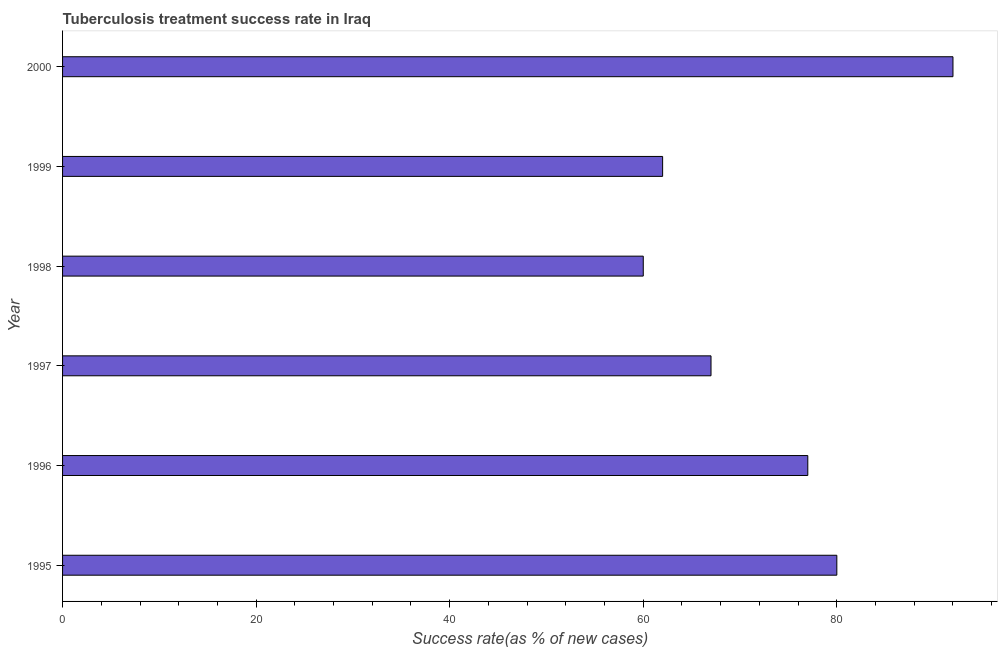Does the graph contain any zero values?
Provide a succinct answer. No. Does the graph contain grids?
Give a very brief answer. No. What is the title of the graph?
Provide a succinct answer. Tuberculosis treatment success rate in Iraq. What is the label or title of the X-axis?
Your answer should be very brief. Success rate(as % of new cases). What is the label or title of the Y-axis?
Ensure brevity in your answer.  Year. Across all years, what is the maximum tuberculosis treatment success rate?
Keep it short and to the point. 92. Across all years, what is the minimum tuberculosis treatment success rate?
Your answer should be compact. 60. In which year was the tuberculosis treatment success rate maximum?
Your response must be concise. 2000. In which year was the tuberculosis treatment success rate minimum?
Provide a short and direct response. 1998. What is the sum of the tuberculosis treatment success rate?
Make the answer very short. 438. What is the difference between the tuberculosis treatment success rate in 1997 and 2000?
Provide a short and direct response. -25. What is the median tuberculosis treatment success rate?
Make the answer very short. 72. Do a majority of the years between 1995 and 1996 (inclusive) have tuberculosis treatment success rate greater than 64 %?
Ensure brevity in your answer.  Yes. What is the ratio of the tuberculosis treatment success rate in 1995 to that in 1996?
Offer a terse response. 1.04. Is the tuberculosis treatment success rate in 1996 less than that in 1997?
Keep it short and to the point. No. Is the difference between the tuberculosis treatment success rate in 1997 and 1999 greater than the difference between any two years?
Offer a very short reply. No. What is the difference between the highest and the second highest tuberculosis treatment success rate?
Offer a very short reply. 12. What is the difference between the highest and the lowest tuberculosis treatment success rate?
Your answer should be very brief. 32. How many years are there in the graph?
Offer a very short reply. 6. What is the difference between two consecutive major ticks on the X-axis?
Your answer should be compact. 20. What is the Success rate(as % of new cases) in 1996?
Offer a very short reply. 77. What is the Success rate(as % of new cases) of 1997?
Offer a terse response. 67. What is the Success rate(as % of new cases) in 1998?
Provide a succinct answer. 60. What is the Success rate(as % of new cases) in 2000?
Offer a very short reply. 92. What is the difference between the Success rate(as % of new cases) in 1995 and 1997?
Provide a succinct answer. 13. What is the difference between the Success rate(as % of new cases) in 1995 and 1998?
Your answer should be very brief. 20. What is the difference between the Success rate(as % of new cases) in 1996 and 1999?
Ensure brevity in your answer.  15. What is the difference between the Success rate(as % of new cases) in 1998 and 1999?
Provide a short and direct response. -2. What is the difference between the Success rate(as % of new cases) in 1998 and 2000?
Offer a very short reply. -32. What is the difference between the Success rate(as % of new cases) in 1999 and 2000?
Provide a succinct answer. -30. What is the ratio of the Success rate(as % of new cases) in 1995 to that in 1996?
Your response must be concise. 1.04. What is the ratio of the Success rate(as % of new cases) in 1995 to that in 1997?
Offer a terse response. 1.19. What is the ratio of the Success rate(as % of new cases) in 1995 to that in 1998?
Give a very brief answer. 1.33. What is the ratio of the Success rate(as % of new cases) in 1995 to that in 1999?
Your answer should be very brief. 1.29. What is the ratio of the Success rate(as % of new cases) in 1995 to that in 2000?
Keep it short and to the point. 0.87. What is the ratio of the Success rate(as % of new cases) in 1996 to that in 1997?
Your response must be concise. 1.15. What is the ratio of the Success rate(as % of new cases) in 1996 to that in 1998?
Offer a very short reply. 1.28. What is the ratio of the Success rate(as % of new cases) in 1996 to that in 1999?
Offer a very short reply. 1.24. What is the ratio of the Success rate(as % of new cases) in 1996 to that in 2000?
Give a very brief answer. 0.84. What is the ratio of the Success rate(as % of new cases) in 1997 to that in 1998?
Offer a terse response. 1.12. What is the ratio of the Success rate(as % of new cases) in 1997 to that in 1999?
Offer a terse response. 1.08. What is the ratio of the Success rate(as % of new cases) in 1997 to that in 2000?
Make the answer very short. 0.73. What is the ratio of the Success rate(as % of new cases) in 1998 to that in 2000?
Provide a succinct answer. 0.65. What is the ratio of the Success rate(as % of new cases) in 1999 to that in 2000?
Offer a very short reply. 0.67. 